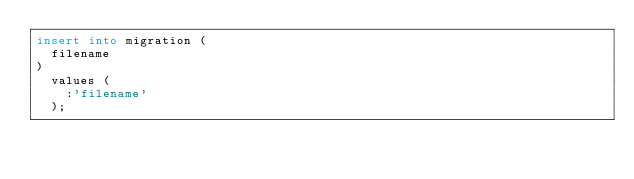<code> <loc_0><loc_0><loc_500><loc_500><_SQL_>insert into migration (
  filename
)
  values (
    :'filename'
  );</code> 